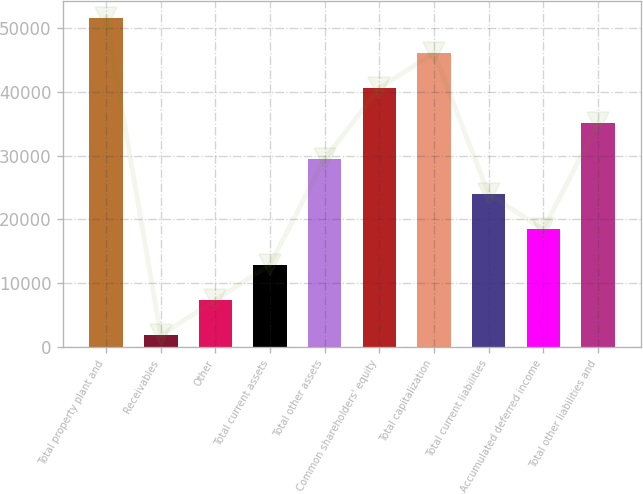Convert chart. <chart><loc_0><loc_0><loc_500><loc_500><bar_chart><fcel>Total property plant and<fcel>Receivables<fcel>Other<fcel>Total current assets<fcel>Total other assets<fcel>Common shareholders' equity<fcel>Total capitalization<fcel>Total current liabilities<fcel>Accumulated deferred income<fcel>Total other liabilities and<nl><fcel>51649.4<fcel>1802<fcel>7340.6<fcel>12879.2<fcel>29495<fcel>40572.2<fcel>46110.8<fcel>23956.4<fcel>18417.8<fcel>35033.6<nl></chart> 